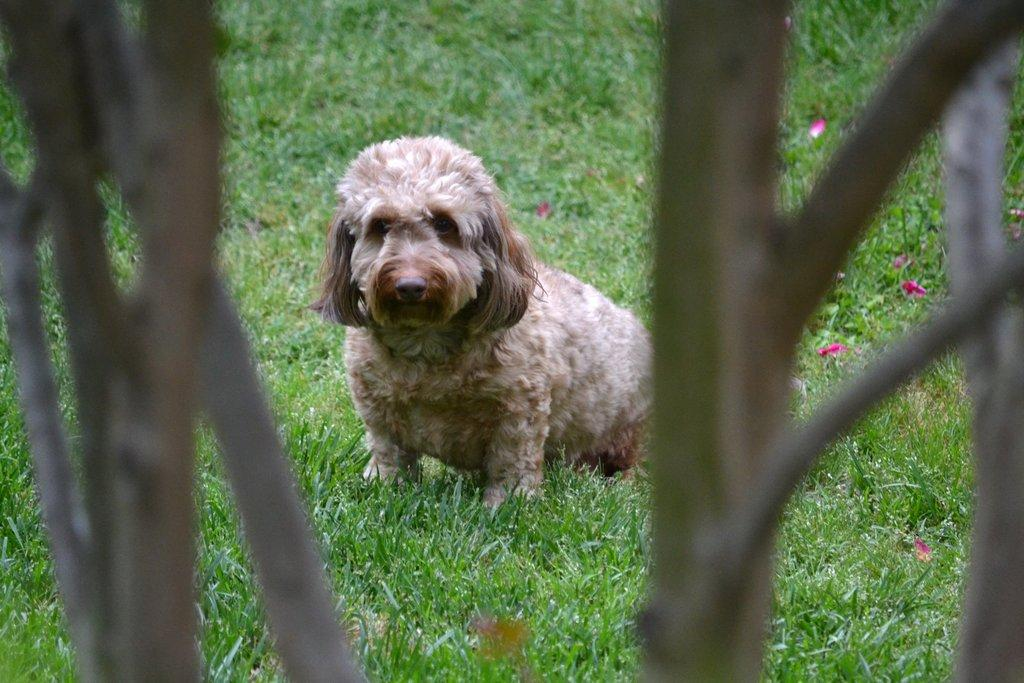What animal can be seen in the image? There is a dog in the image. Where is the dog located? The dog is on the grass. What can be seen on the sides of the image? There are branches visible on the left and right sides of the image. How many ducks are swimming in the drink in the image? There are no ducks or drinks present in the image; it features a dog on the grass with branches on the sides. 